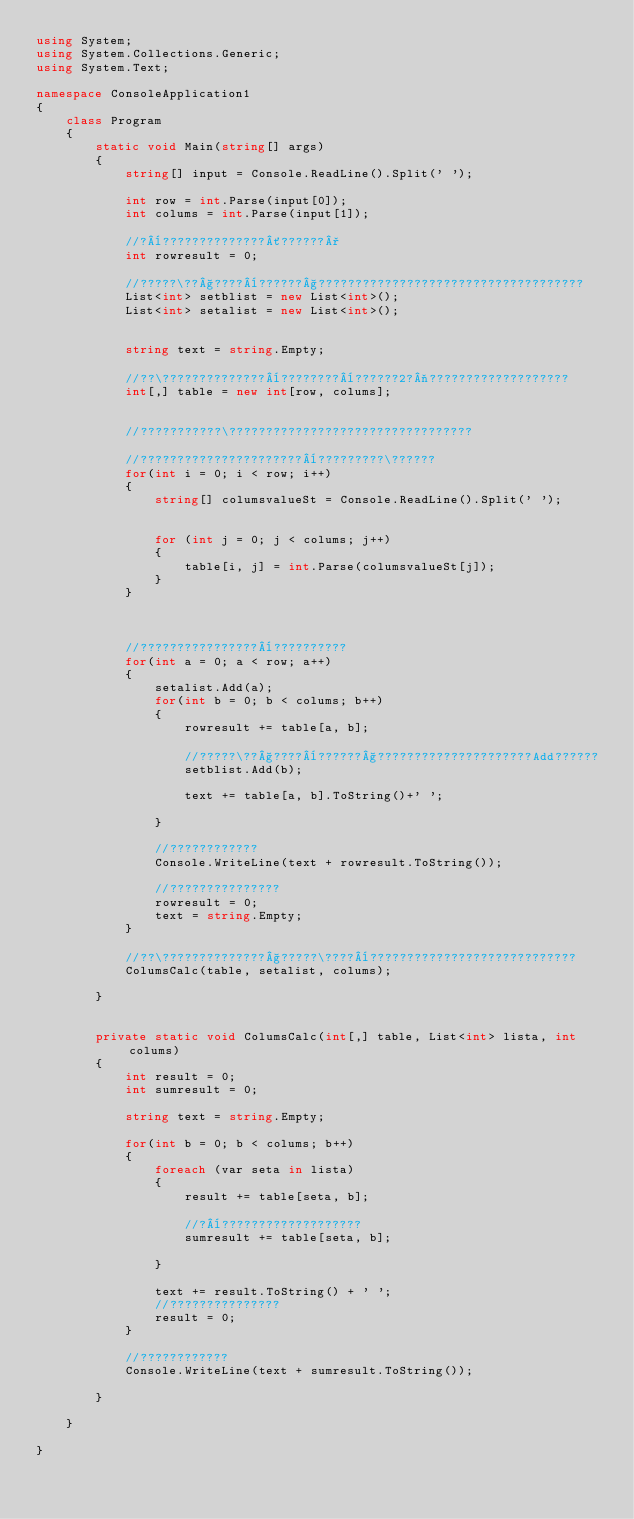<code> <loc_0><loc_0><loc_500><loc_500><_C#_>using System;
using System.Collections.Generic;
using System.Text;

namespace ConsoleApplication1
{
    class Program
    {     
        static void Main(string[] args)
        {
            string[] input = Console.ReadLine().Split(' ');

            int row = int.Parse(input[0]);
            int colums = int.Parse(input[1]);

            //?¨??????????????´??????°
            int rowresult = 0;

            //?????\??§????¨??????§????????????????????????????????????
            List<int> setblist = new List<int>();
            List<int> setalist = new List<int>();


            string text = string.Empty;

            //??\??????????????¨????????¨??????2?¬???????????????????
            int[,] table = new int[row, colums];


            //???????????\?????????????????????????????????

            //??????????????????????¨?????????\??????
            for(int i = 0; i < row; i++)
            {
                string[] columsvalueSt = Console.ReadLine().Split(' ');


                for (int j = 0; j < colums; j++)
                {
                    table[i, j] = int.Parse(columsvalueSt[j]);
                }
            }



            //????????????????¨??????????
            for(int a = 0; a < row; a++)
            {
                setalist.Add(a);
                for(int b = 0; b < colums; b++)
                {
                    rowresult += table[a, b];

                    //?????\??§????¨??????§?????????????????????Add??????
                    setblist.Add(b);

                    text += table[a, b].ToString()+' ';

                }

                //????????????
                Console.WriteLine(text + rowresult.ToString());

                //???????????????
                rowresult = 0;
                text = string.Empty;
            }

            //??\??????????????§?????\????¨????????????????????????????
            ColumsCalc(table, setalist, colums);

        }


        private static void ColumsCalc(int[,] table, List<int> lista, int colums)
        {
            int result = 0;
            int sumresult = 0;

            string text = string.Empty;

            for(int b = 0; b < colums; b++)
            {
                foreach (var seta in lista)
                {
                    result += table[seta, b];

                    //?¨???????????????????
                    sumresult += table[seta, b];

                }

                text += result.ToString() + ' ';
                //???????????????
                result = 0;
            }

            //????????????
            Console.WriteLine(text + sumresult.ToString());

        }
    
    }

}</code> 